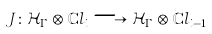<formula> <loc_0><loc_0><loc_500><loc_500>J \colon \mathcal { H } _ { \Gamma } \otimes \mathbb { C } l _ { i } \longrightarrow \mathcal { H } _ { \Gamma } \otimes \mathbb { C } l _ { i - 1 }</formula> 